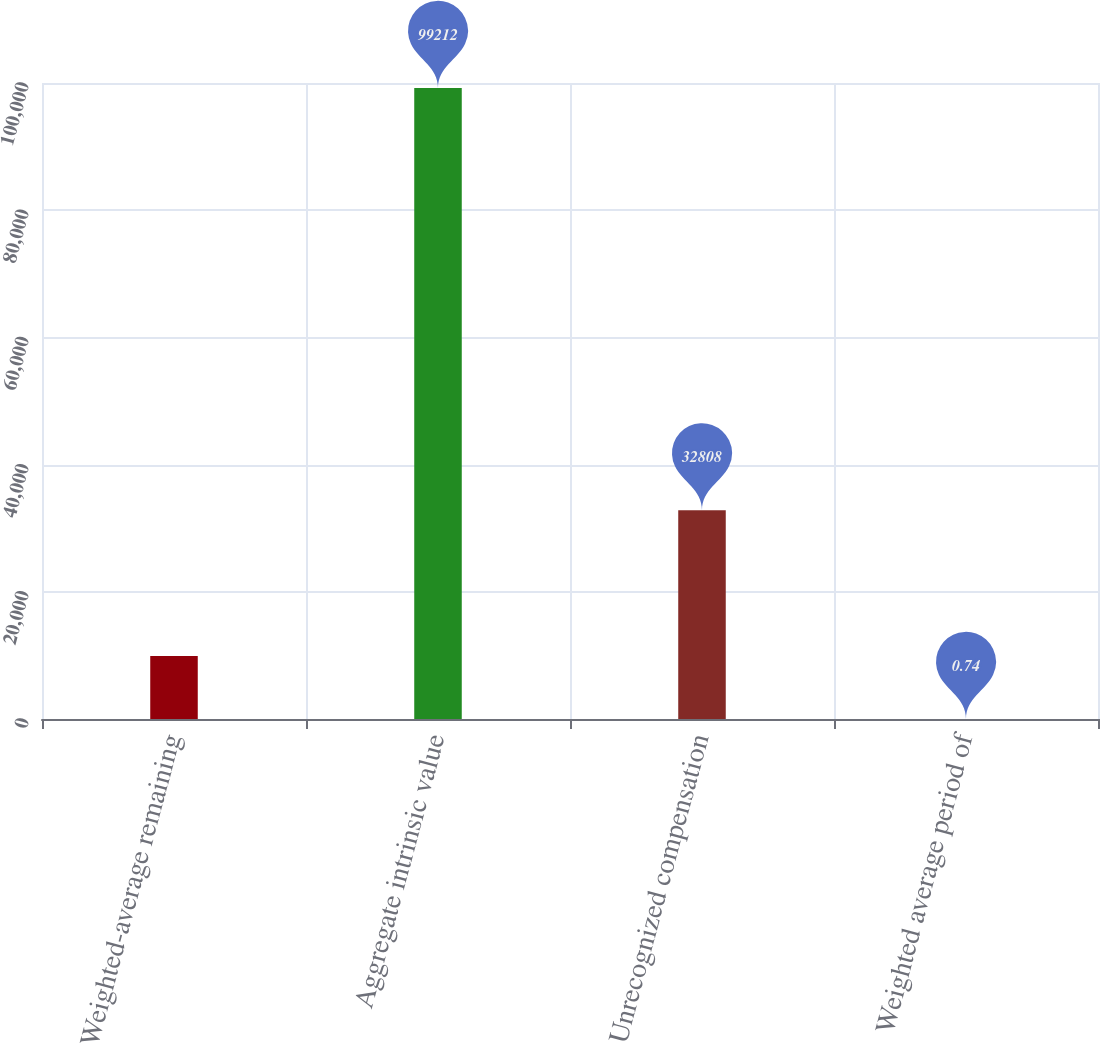<chart> <loc_0><loc_0><loc_500><loc_500><bar_chart><fcel>Weighted-average remaining<fcel>Aggregate intrinsic value<fcel>Unrecognized compensation<fcel>Weighted average period of<nl><fcel>9921.87<fcel>99212<fcel>32808<fcel>0.74<nl></chart> 